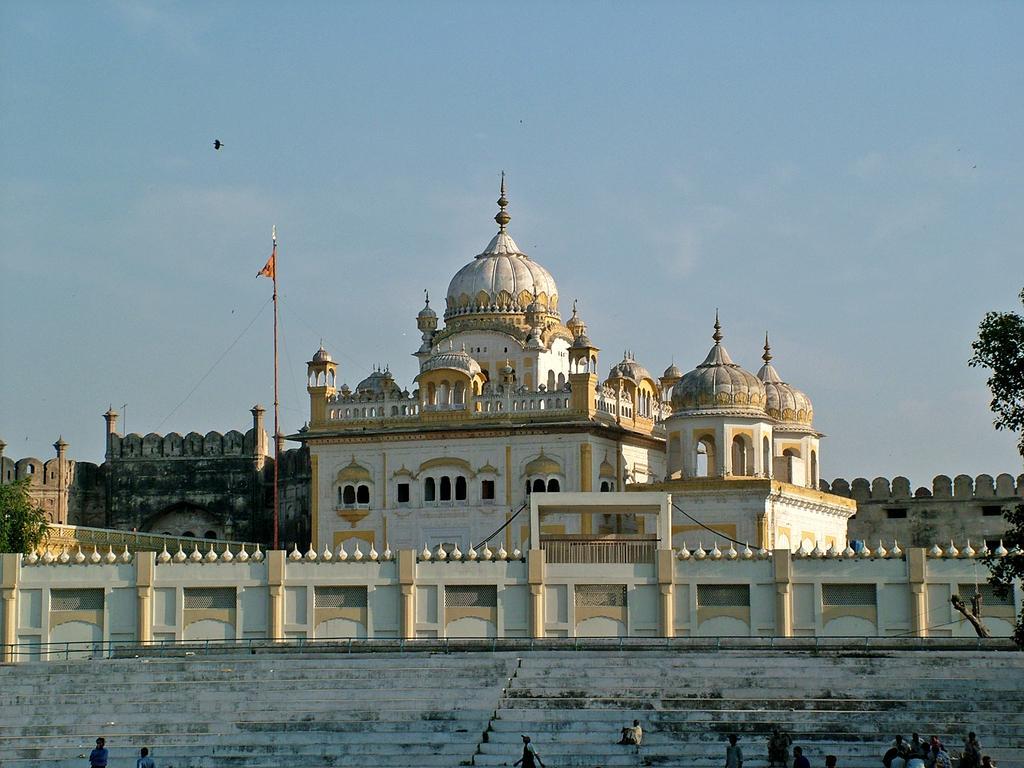Please provide a concise description of this image. This picture is clicked outside. In the foreground we can see the group of persons and the stairs. In the center we can see the buildings and the domes attached to the buildings and there is a flag attached to the pole. In the background there is a sky and some trees. 